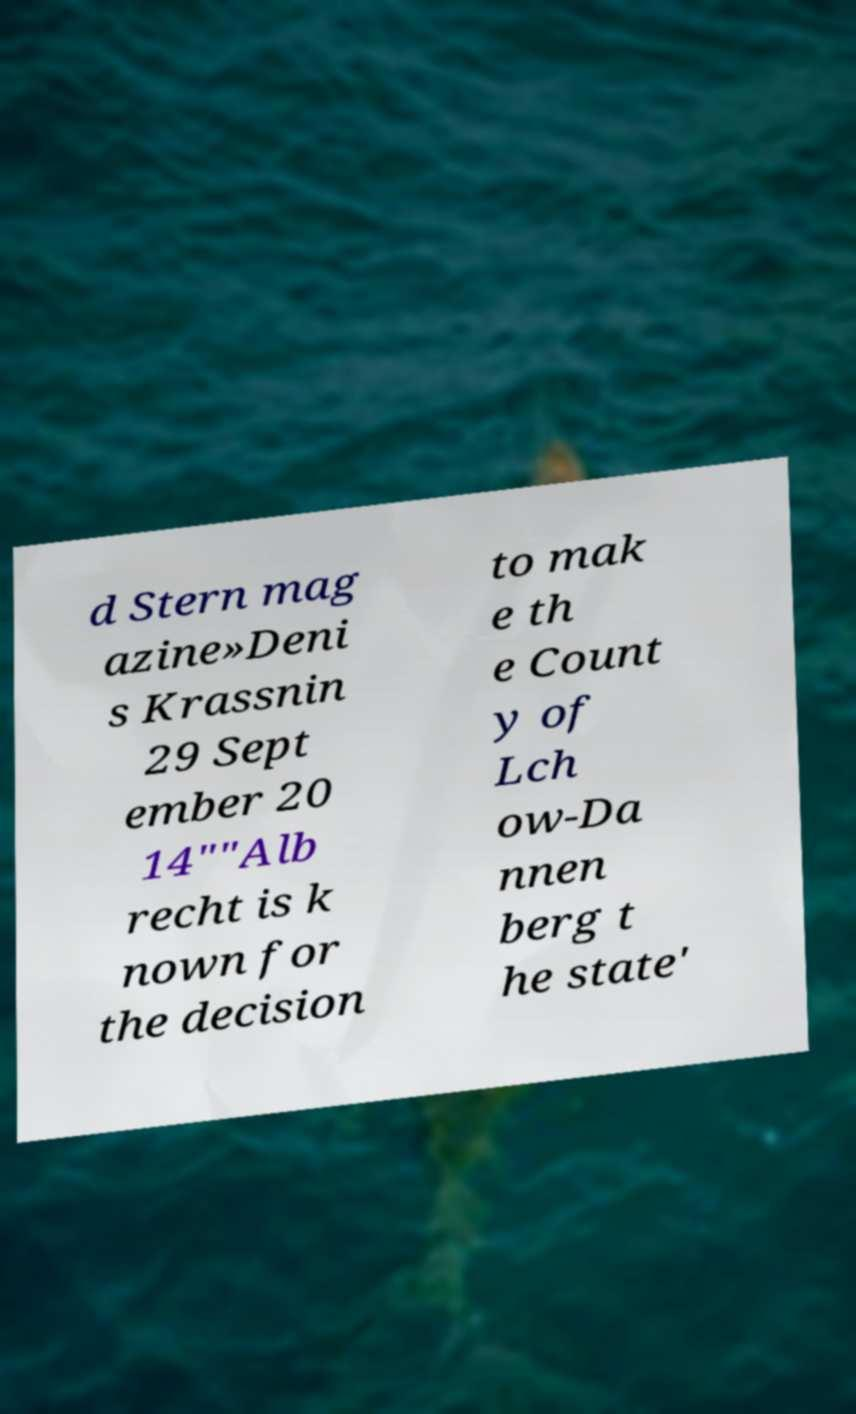Can you read and provide the text displayed in the image?This photo seems to have some interesting text. Can you extract and type it out for me? d Stern mag azine»Deni s Krassnin 29 Sept ember 20 14""Alb recht is k nown for the decision to mak e th e Count y of Lch ow-Da nnen berg t he state' 